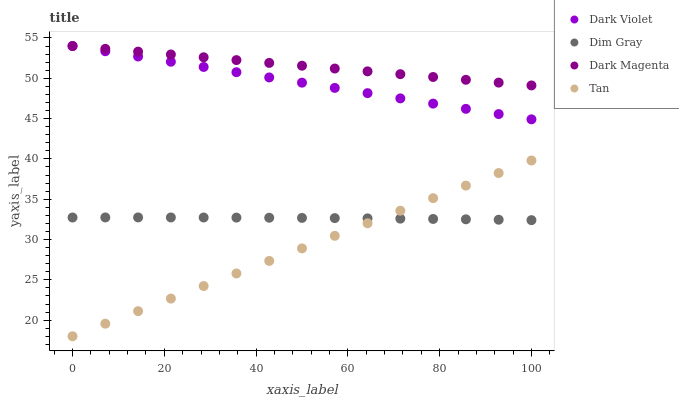Does Tan have the minimum area under the curve?
Answer yes or no. Yes. Does Dark Magenta have the maximum area under the curve?
Answer yes or no. Yes. Does Dim Gray have the minimum area under the curve?
Answer yes or no. No. Does Dim Gray have the maximum area under the curve?
Answer yes or no. No. Is Tan the smoothest?
Answer yes or no. Yes. Is Dim Gray the roughest?
Answer yes or no. Yes. Is Dark Magenta the smoothest?
Answer yes or no. No. Is Dark Magenta the roughest?
Answer yes or no. No. Does Tan have the lowest value?
Answer yes or no. Yes. Does Dim Gray have the lowest value?
Answer yes or no. No. Does Dark Violet have the highest value?
Answer yes or no. Yes. Does Dim Gray have the highest value?
Answer yes or no. No. Is Dim Gray less than Dark Magenta?
Answer yes or no. Yes. Is Dark Violet greater than Tan?
Answer yes or no. Yes. Does Tan intersect Dim Gray?
Answer yes or no. Yes. Is Tan less than Dim Gray?
Answer yes or no. No. Is Tan greater than Dim Gray?
Answer yes or no. No. Does Dim Gray intersect Dark Magenta?
Answer yes or no. No. 